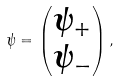Convert formula to latex. <formula><loc_0><loc_0><loc_500><loc_500>\psi = \left ( \begin{matrix} \psi _ { + } \\ \psi _ { - } \end{matrix} \right ) ,</formula> 